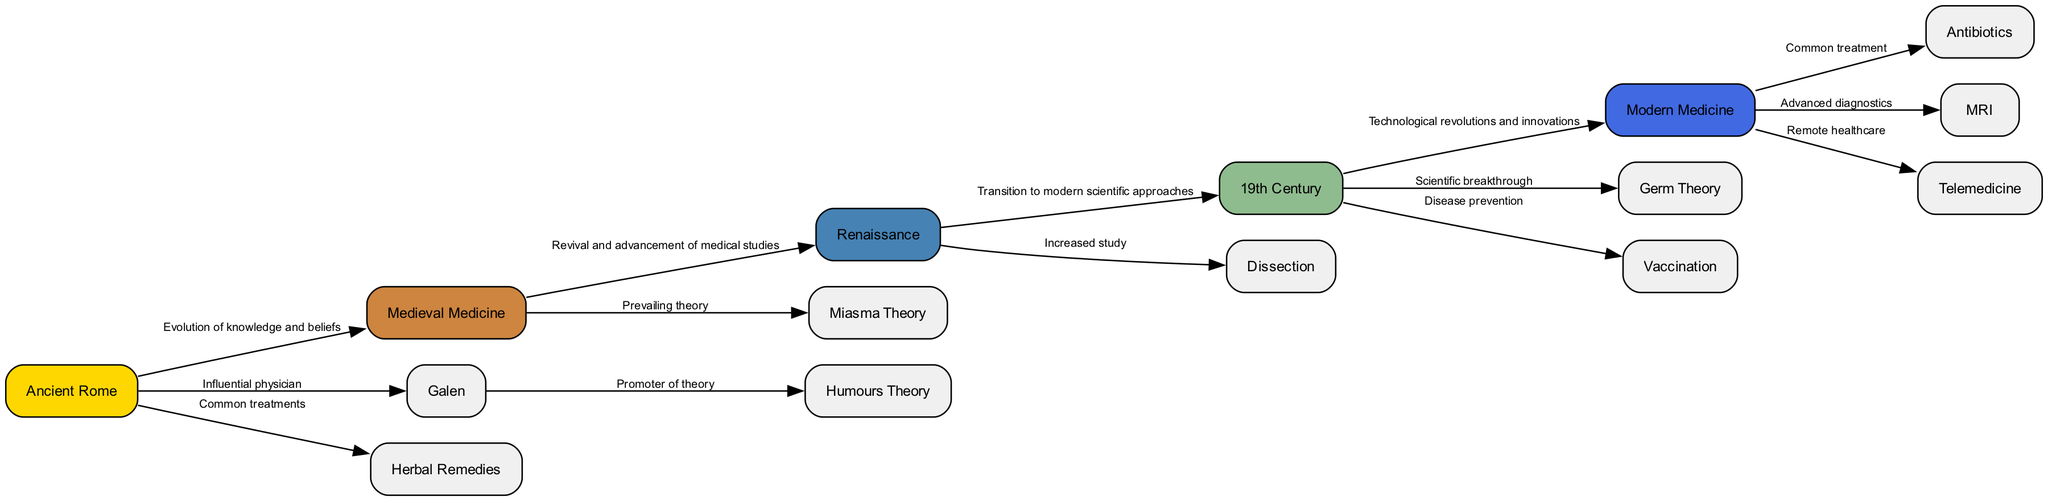What is the first node in the diagram? The first node is labeled "Ancient Rome" which represents the starting point of the evolution of disease treatment methods.
Answer: Ancient Rome How many nodes are present in the diagram? By counting the nodes listed in the data, there are 15 nodes that represent different eras and treatment methods.
Answer: 15 What is the edge label connecting Medieval Medicine to Renaissance? The edge label indicates the relationship as "Revival and advancement of medical studies," showing that knowledge progressed from Medieval Medicine to the Renaissance.
Answer: Revival and advancement of medical studies What prevailing theory was recognized during Medieval Medicine? The diagram specifies "Miasma Theory" as the prevailing belief during the Medieval period regarding disease spread.
Answer: Miasma Theory Which theory did Galen promote during Ancient Rome? According to the diagram, Galen is associated with promoting the "Humours Theory," which was a significant belief about health in his time.
Answer: Humours Theory What treatment method was introduced during the 19th Century? The 19th Century is associated with the introduction of "Vaccination," a key development in disease prevention highlighted in the diagram.
Answer: Vaccination Which medical practice introduced advanced diagnostics in Modern Medicine? The diagram mentions "MRI" as the advanced diagnostic tool introduced during the Modern Medicine era.
Answer: MRI How did the approach to treatment change from the Renaissance to the 19th Century? The diagram indicates a "Transition to modern scientific approaches" as the change between these two periods, reflecting advancements in medical understanding.
Answer: Transition to modern scientific approaches What is one common treatment used in Ancient Rome? The diagram lists "Herbal Remedies" as one of the common treatment methods utilized in Ancient Rome.
Answer: Herbal Remedies 